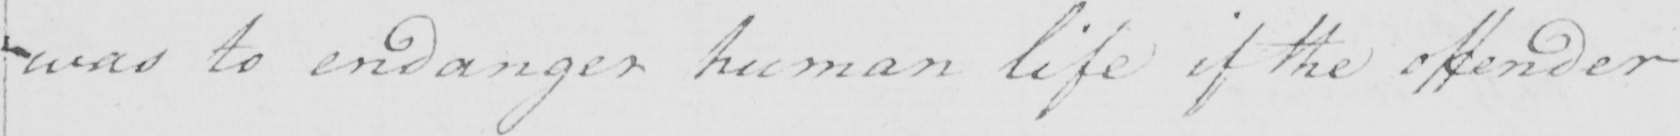Please provide the text content of this handwritten line. was to endanger human life if the offender 